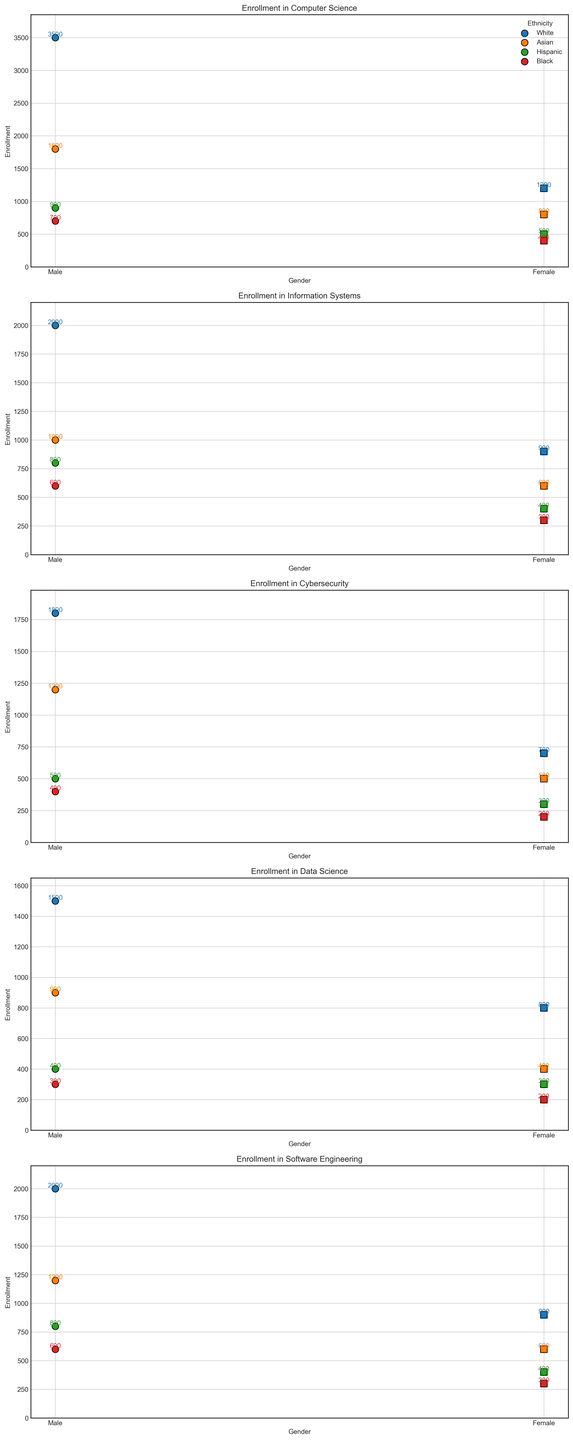What is the total enrollment for Hispanic females across all IT programs? To find the total enrollment for Hispanic females, sum the data points associated with this subgroup across all majors: 500 (CS) + 400 (IS) + 300 (Cybersecurity) + 300 (Data Science) + 400 (Software Engineering) = 1900
Answer: 1900 Which major has the highest enrollment for Black males? Look at the enrollment numbers for Black males across all majors and identify the highest one:
700 (CS), 600 (IS), 400 (Cybersecurity), 300 (Data Science), 600 (Software Engineering).
Computer Science has the highest enrollment for Black males at 700.
Answer: Computer Science In the field of Cybersecurity, what is the difference in enrollment between White males and Asian females? Find the enrollment numbers for White males and Asian females in Cybersecurity: 1800 (White males) - 500 (Asian females) = 1300
Answer: 1300 How does the enrollment of White females in Data Science compare to White females in Information Systems? Compare the enrollment numbers for White females in both majors:
800 (Data Science) vs. 900 (Information Systems).
White females have higher enrollment in Information Systems.
Answer: Information Systems What is the average enrollment for Asian males across all IT programs? Compute the average by summing the enrollments for Asian males across all majors and dividing by the number of majors: (1800 (CS) + 1000 (IS) + 1200 (Cybersecurity) + 900 (Data Science) + 1200 (Software Engineering)) / 5 = 1020
Answer: 1020 Which ethnicity has the least female enrollment in Software Engineering? Check the female enrollment numbers across all ethnicities in Software Engineering:
White (900), Asian (600), Hispanic (400), Black (300).
Black females have the least enrollment in Software Engineering.
Answer: Black In Computer Science, which gender has a higher enrollment among Hispanic students? Compare the enrollment numbers for Hispanic males and females in Computer Science:
900 (males) vs. 500 (females).
Hispanic males have higher enrollment.
Answer: Male What is the combined enrollment for Black females in both Data Science and Software Engineering? Add the enrollment numbers for Black females in Data Science and Software Engineering:
200 (Data Science) + 300 (Software Engineering) = 500
Answer: 500 